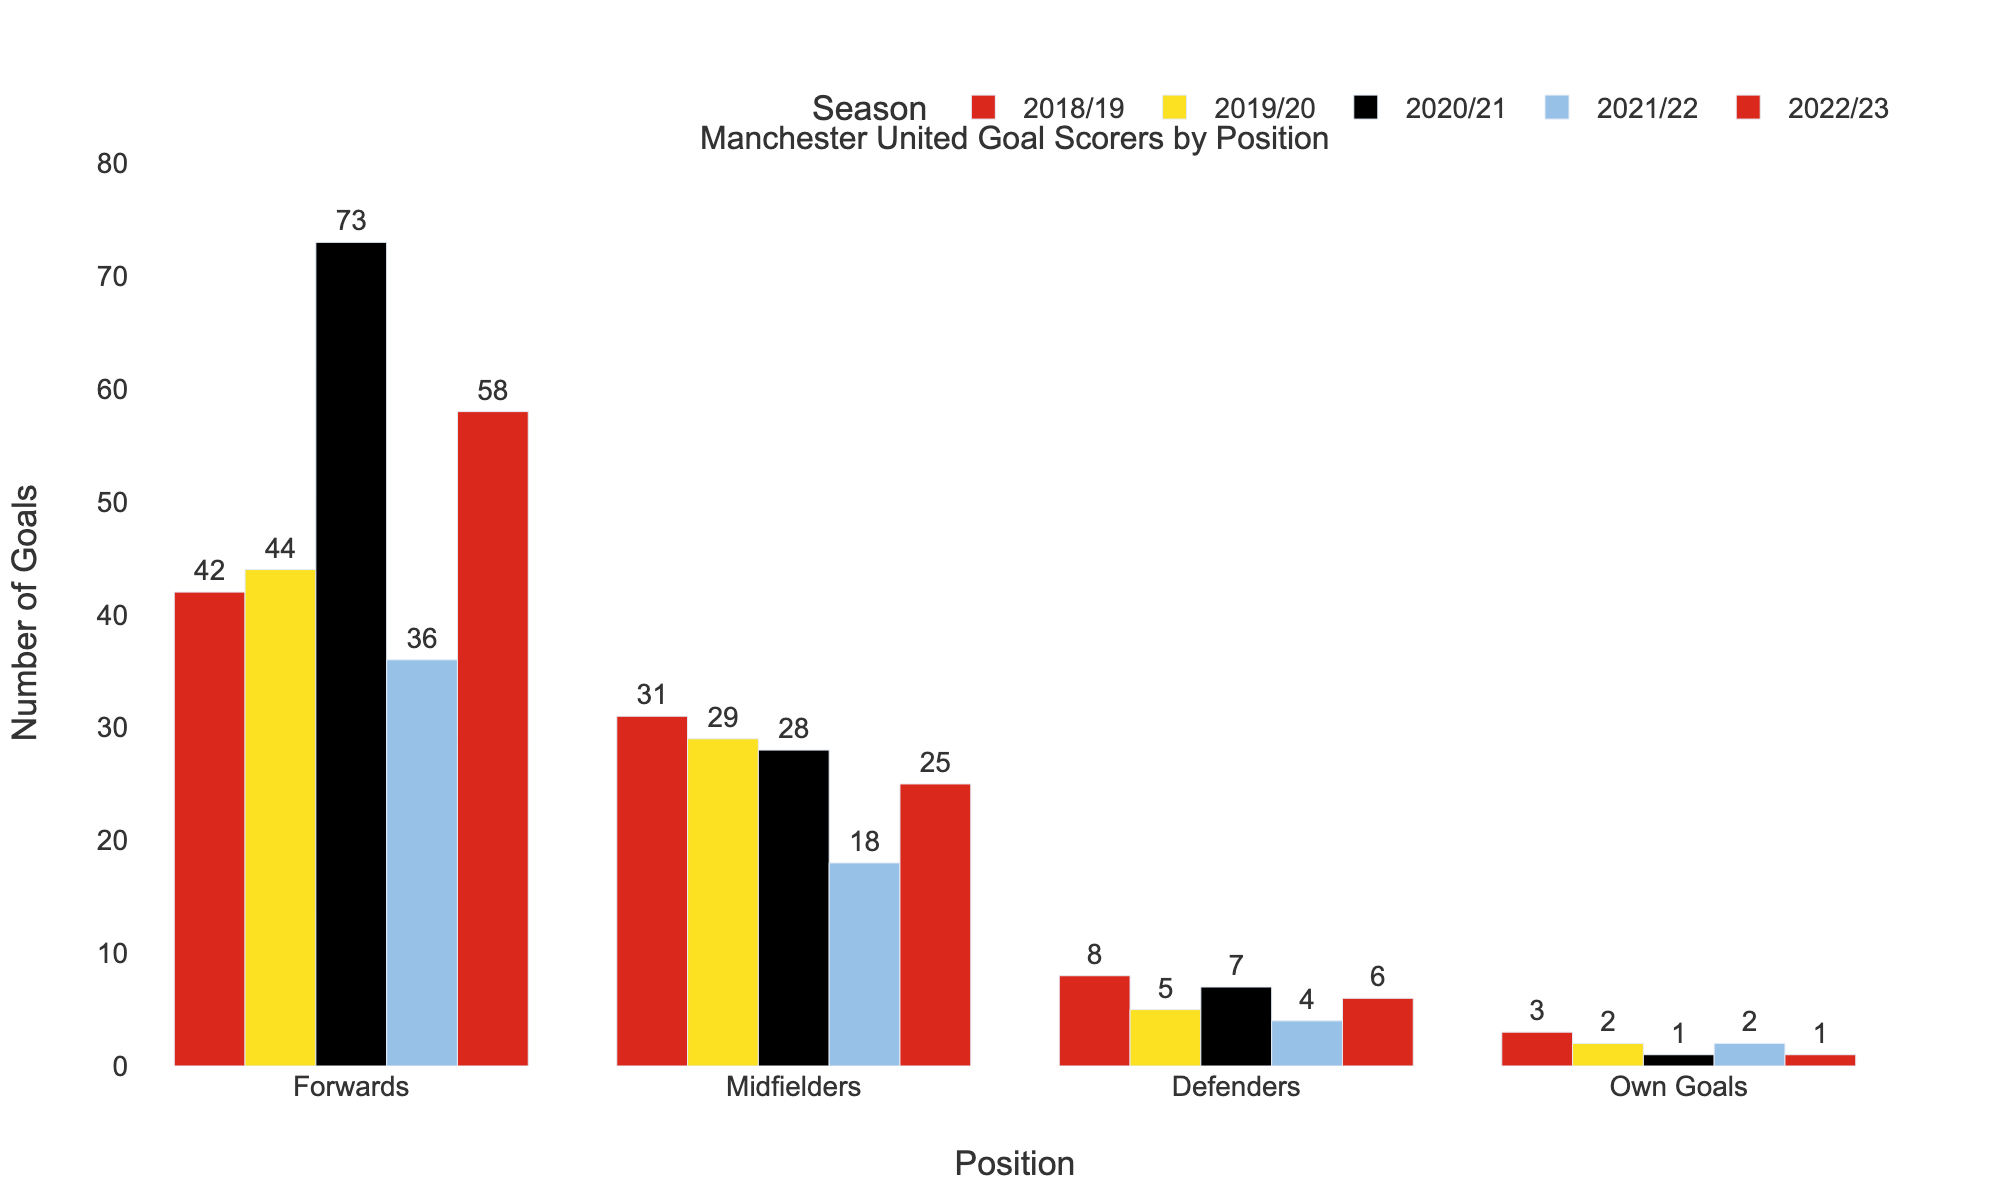Which position scored the most goals in the 2020/21 season? The tallest bar in the 2020/21 group represents the Forwards, which scored 73 goals.
Answer: Forwards Which season did the midfielders score the fewest goals? Looking at the shortest bar in the Midfielders category, it corresponds to the 2021/22 season with 18 goals.
Answer: 2021/22 How many goals did the defenders score in total over the past 5 seasons? Sum the goals scored by defenders: 8 (2018/19) + 5 (2019/20) + 7 (2020/21) + 4 (2021/22) + 6 (2022/23) = 30.
Answer: 30 Which season had the highest total number of goals for all positions combined? Calculate the total for each season: 
2018/19: 42 (Forwards) + 31 (Midfielders) + 8 (Defenders) + 3 (Own Goals) = 84 
2019/20: 44 (Forwards) + 29 (Midfielders) + 5 (Defenders) + 2 (Own Goals) = 80 
2020/21: 73 (Forwards) + 28 (Midfielders) + 7 (Defenders) + 1 (Own Goals) = 109 
2021/22: 36 (Forwards) + 18 (Midfielders) + 4 (Defenders) + 2 (Own Goals) = 60 
2022/23: 58 (Forwards) + 25 (Midfielders) + 6 (Defenders) + 1 (Own Goals) = 90; 
The highest total is 109 in the 2020/21 season.
Answer: 2020/21 By how many goals did the forwards’ lowest scoring season differ from their highest scoring season? The fewer goals by the forwards was 36 (2021/22) and the highest was 73 (2020/21); 73 - 36 = 37.
Answer: 37 In which season was the proportion of goals from midfielders the lowest, relative to the total goals for that season? Calculate the proportion of goals from midfielders for each season: 
2018/19: 31/84 ≈ 0.37 
2019/20: 29/80 ≈ 0.36 
2020/21: 28/109 ≈ 0.26 
2021/22: 18/60 ≈ 0.30 
2022/23: 25/90 ≈ 0.28;
The lowest proportion is 0.26 in the 2020/21 season.
Answer: 2020/21 Which position scored more goals in 2019/20: defenders or own goals? Compare the heights of the bars in the 2019/20 category, Defenders scored 5 goals whereas Own Goals scored 2.
Answer: Defenders What's the total number of own goals scored over the 5 seasons? Sum the goals from own goals: 3 (2018/19) + 2 (2019/20) + 1 (2020/21) + 2 (2021/22) + 1 (2022/23) = 9.
Answer: 9 By how many goals did the midfielders' total goals differ from the defenders' total goals over the 5 seasons? Calculate the total number of goals for each:
Midfielders: 31 + 29 + 28 + 18 + 25 = 131;
Defenders: 8 + 5 + 7 + 4 + 6 = 30;
The difference is 131 - 30 = 101.
Answer: 101 How many more goals did the forwards score than midfielders in the 2022/23 season? The forwards scored 58 goals and the midfielders scored 25 goals in the 2022/23 season; 58 - 25 = 33.
Answer: 33 